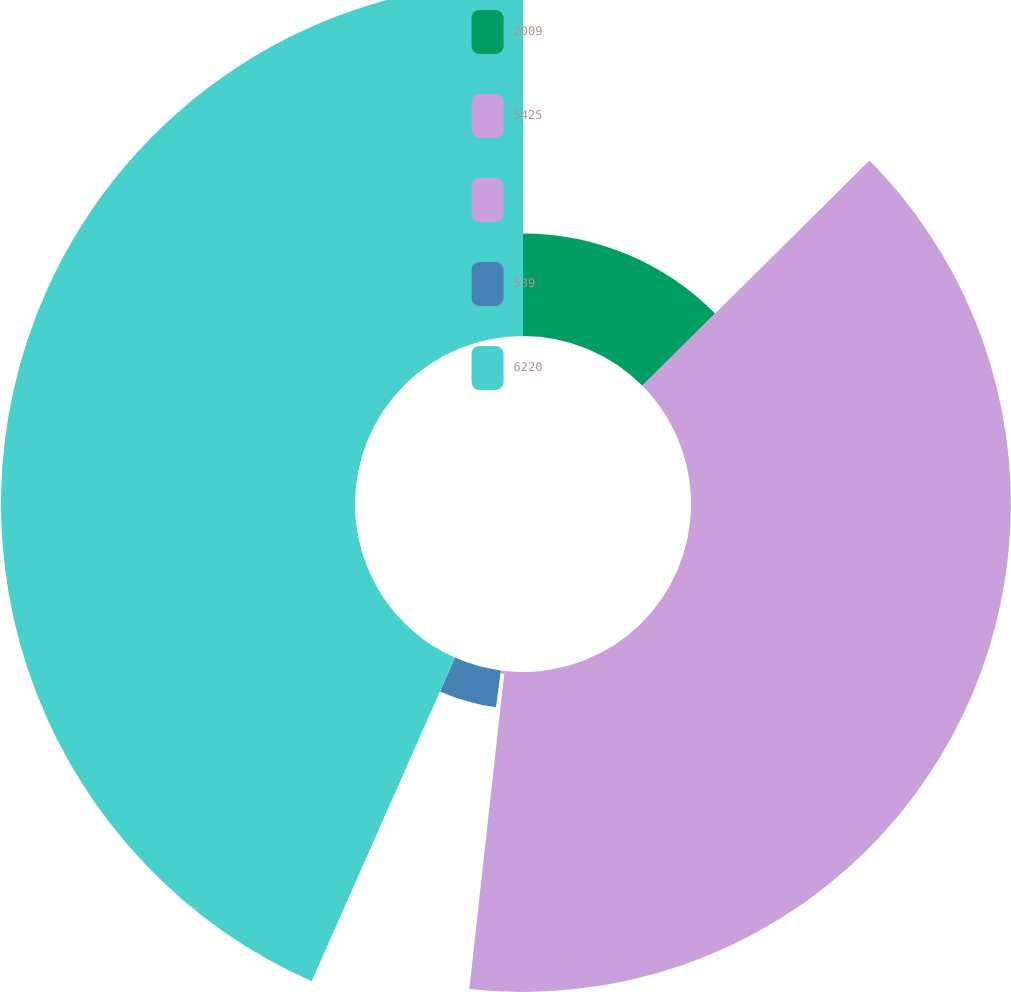<chart> <loc_0><loc_0><loc_500><loc_500><pie_chart><fcel>2009<fcel>5425<fcel>-<fcel>539<fcel>6220<nl><fcel>12.57%<fcel>39.19%<fcel>0.35%<fcel>4.53%<fcel>43.37%<nl></chart> 